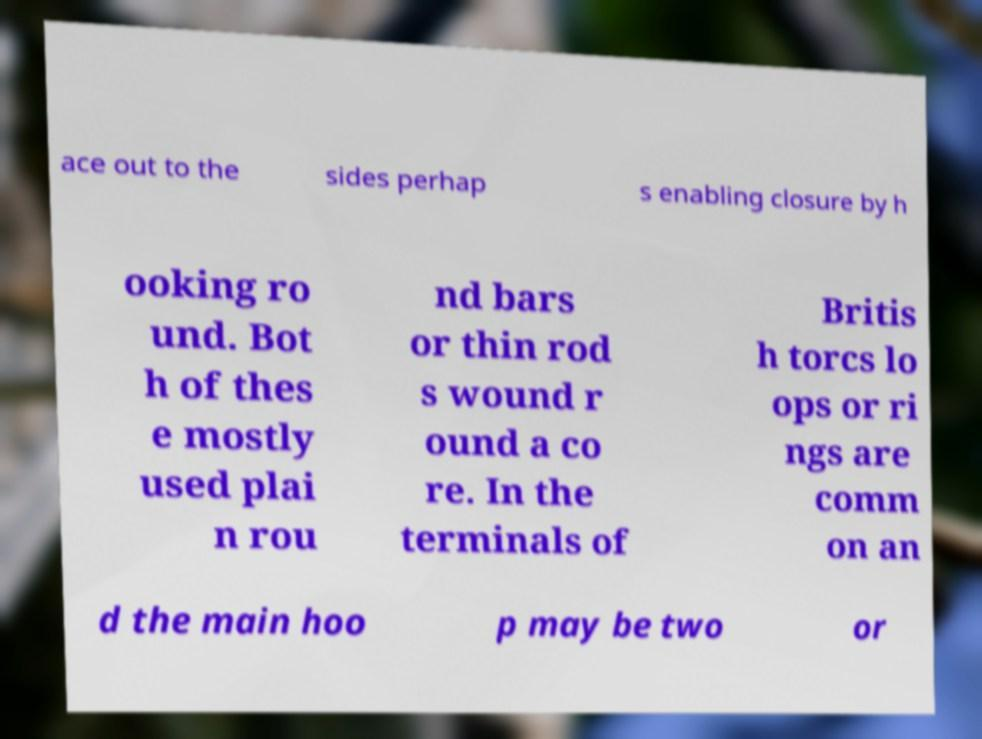For documentation purposes, I need the text within this image transcribed. Could you provide that? ace out to the sides perhap s enabling closure by h ooking ro und. Bot h of thes e mostly used plai n rou nd bars or thin rod s wound r ound a co re. In the terminals of Britis h torcs lo ops or ri ngs are comm on an d the main hoo p may be two or 